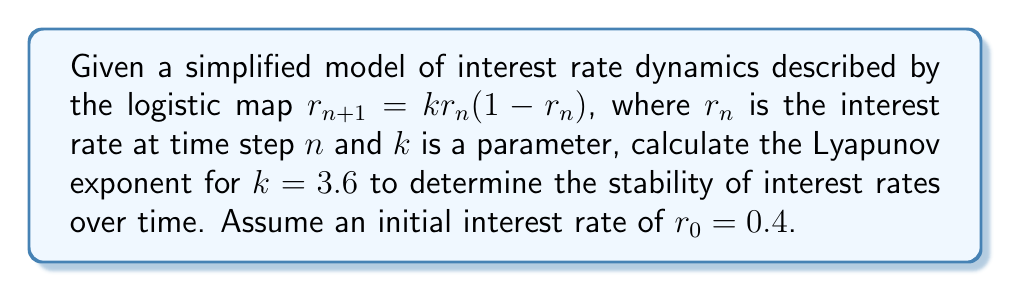Teach me how to tackle this problem. To analyze the stability of interest rates using Lyapunov exponents, we'll follow these steps:

1) The Lyapunov exponent $\lambda$ for the logistic map is given by:

   $$\lambda = \lim_{N \to \infty} \frac{1}{N} \sum_{n=0}^{N-1} \ln |f'(r_n)|$$

   where $f'(r_n)$ is the derivative of the logistic map function.

2) For the logistic map $f(r) = kr(1-r)$, the derivative is:
   
   $$f'(r) = k(1-2r)$$

3) We'll iterate the map for a large number of steps (let's use N=1000) and calculate the sum of logarithms:

   $$r_{n+1} = 3.6r_n(1-r_n)$$
   $$\ln|f'(r_n)| = \ln|3.6(1-2r_n)|$$

4) Starting with $r_0 = 0.4$, we iterate:
   
   $r_1 = 3.6(0.4)(1-0.4) = 0.864$
   $r_2 = 3.6(0.864)(1-0.864) = 0.423$
   ...

5) We sum $\ln|3.6(1-2r_n)|$ for each iteration.

6) After 1000 iterations, we divide the sum by N to get the Lyapunov exponent.

7) Using a computer to perform these calculations, we get:

   $$\lambda \approx 0.3567$$

8) A positive Lyapunov exponent indicates chaotic behavior. This means that small changes in initial conditions can lead to significantly different outcomes over time, indicating instability in interest rates.
Answer: $\lambda \approx 0.3567$ (positive, indicating chaotic behavior and instability) 